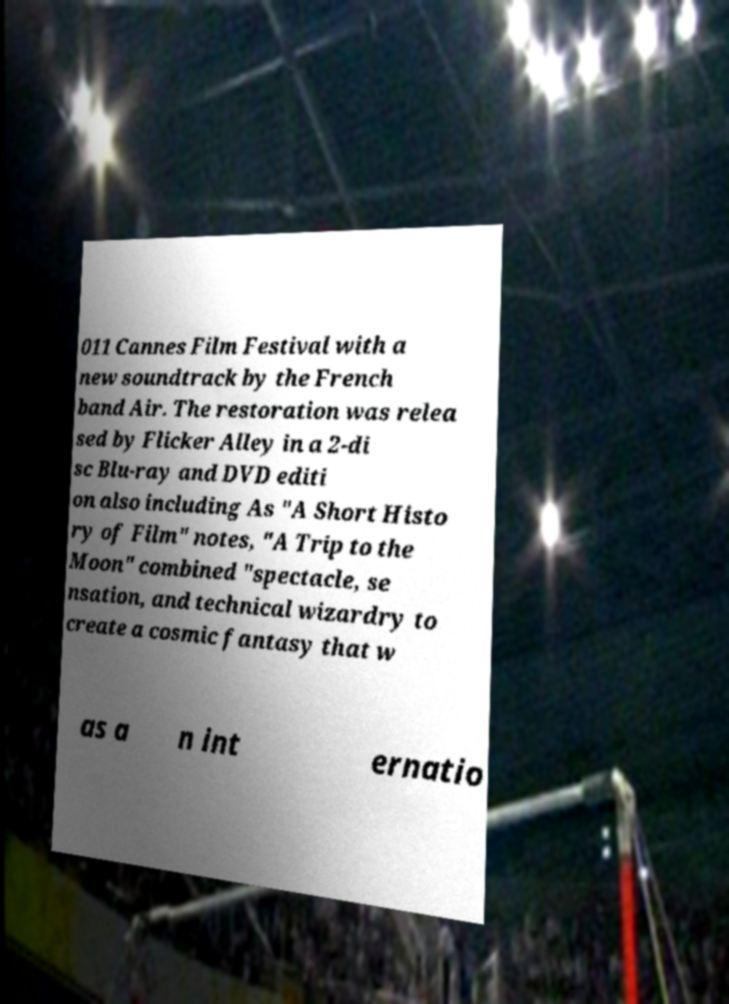Could you assist in decoding the text presented in this image and type it out clearly? 011 Cannes Film Festival with a new soundtrack by the French band Air. The restoration was relea sed by Flicker Alley in a 2-di sc Blu-ray and DVD editi on also including As "A Short Histo ry of Film" notes, "A Trip to the Moon" combined "spectacle, se nsation, and technical wizardry to create a cosmic fantasy that w as a n int ernatio 